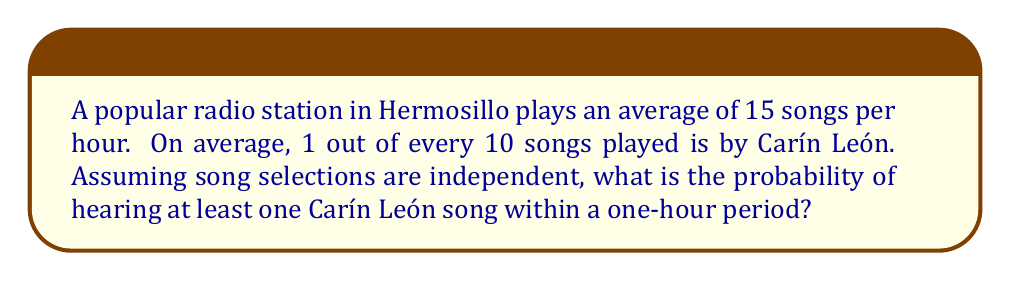Teach me how to tackle this problem. Let's approach this step-by-step:

1) First, let's define our probability:
   $p$ = probability of a song being by Carín León = $\frac{1}{10}$

2) The probability of a song not being by Carín León is:
   $1 - p = \frac{9}{10}$

3) In one hour, there are 15 songs played. We want to find the probability of hearing at least one Carín León song, which is the opposite of hearing no Carín León songs.

4) The probability of hearing no Carín León songs in 15 tries is:
   $(\frac{9}{10})^{15}$

5) Therefore, the probability of hearing at least one Carín León song is:
   $1 - (\frac{9}{10})^{15}$

6) Let's calculate this:
   $$1 - (\frac{9}{10})^{15} = 1 - 0.2058 = 0.7942$$

7) Converting to a percentage:
   $0.7942 \times 100\% = 79.42\%$

Thus, there is a 79.42% chance of hearing at least one Carín León song within an hour on this Hermosillo radio station.
Answer: 79.42% 